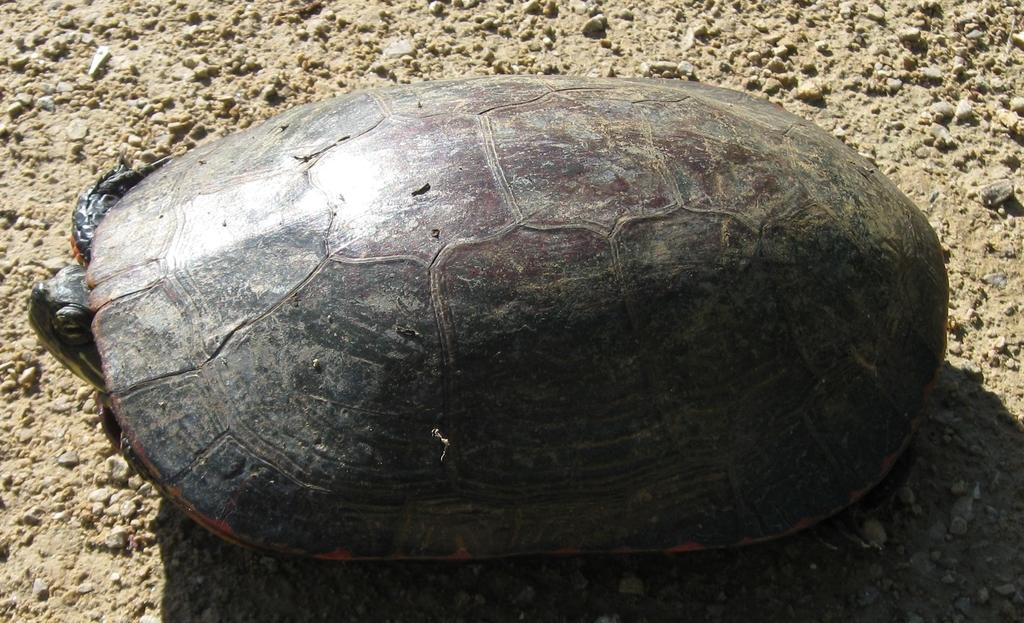What type of animal is in the image? There is a tortoise in the image. What is the tortoise's location in the image? The tortoise is on the sand. What type of throne does the tortoise sit on in the image? There is no throne present in the image; the tortoise is on the sand. What position does the tortoise hold in the image? The tortoise is simply an animal in the image and does not hold any position. 